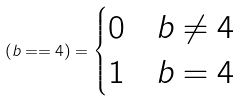Convert formula to latex. <formula><loc_0><loc_0><loc_500><loc_500>( b = = 4 ) = \begin{cases} 0 & b \neq 4 \\ 1 & b = 4 \end{cases}</formula> 